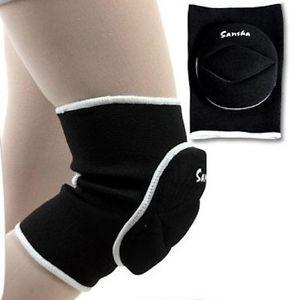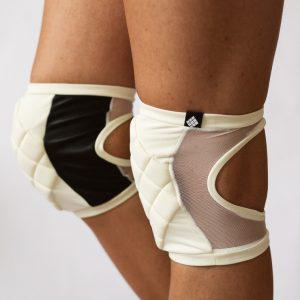The first image is the image on the left, the second image is the image on the right. Assess this claim about the two images: "there is a pair of knee pads with mesh sides and a cut out behind the knee". Correct or not? Answer yes or no. Yes. The first image is the image on the left, the second image is the image on the right. For the images displayed, is the sentence "Only black kneepads are shown, and the left and right images contain the same number of kneepads." factually correct? Answer yes or no. No. 